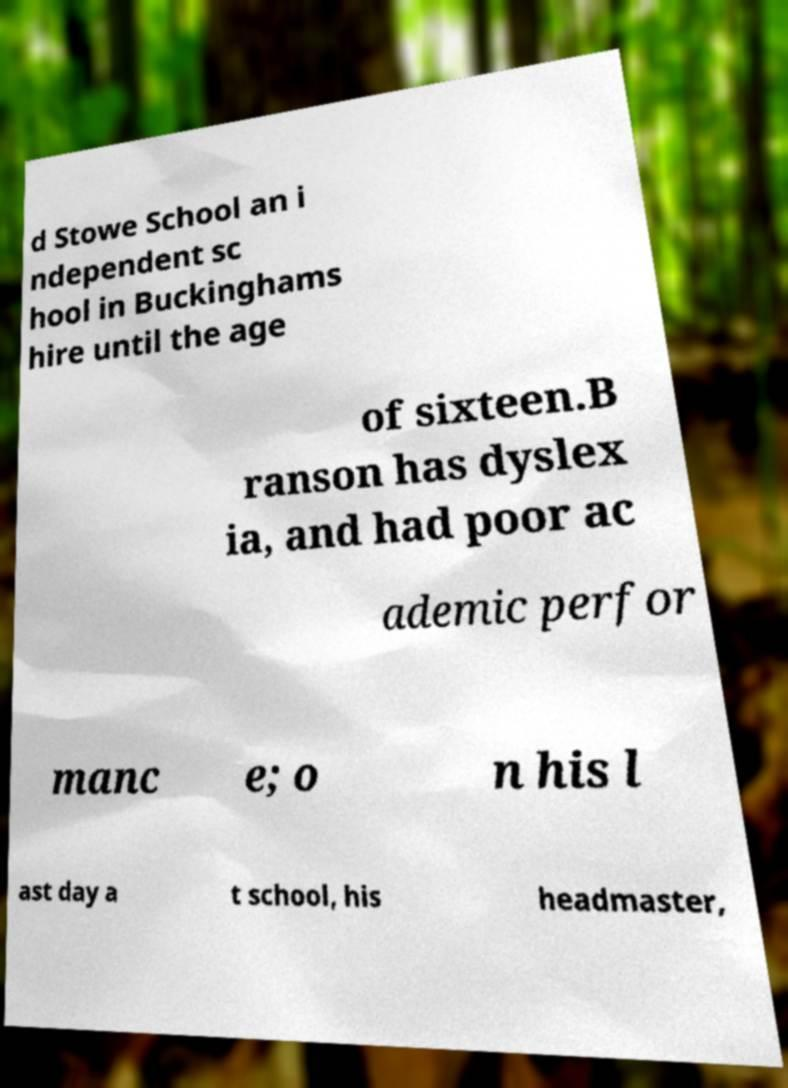Please identify and transcribe the text found in this image. d Stowe School an i ndependent sc hool in Buckinghams hire until the age of sixteen.B ranson has dyslex ia, and had poor ac ademic perfor manc e; o n his l ast day a t school, his headmaster, 